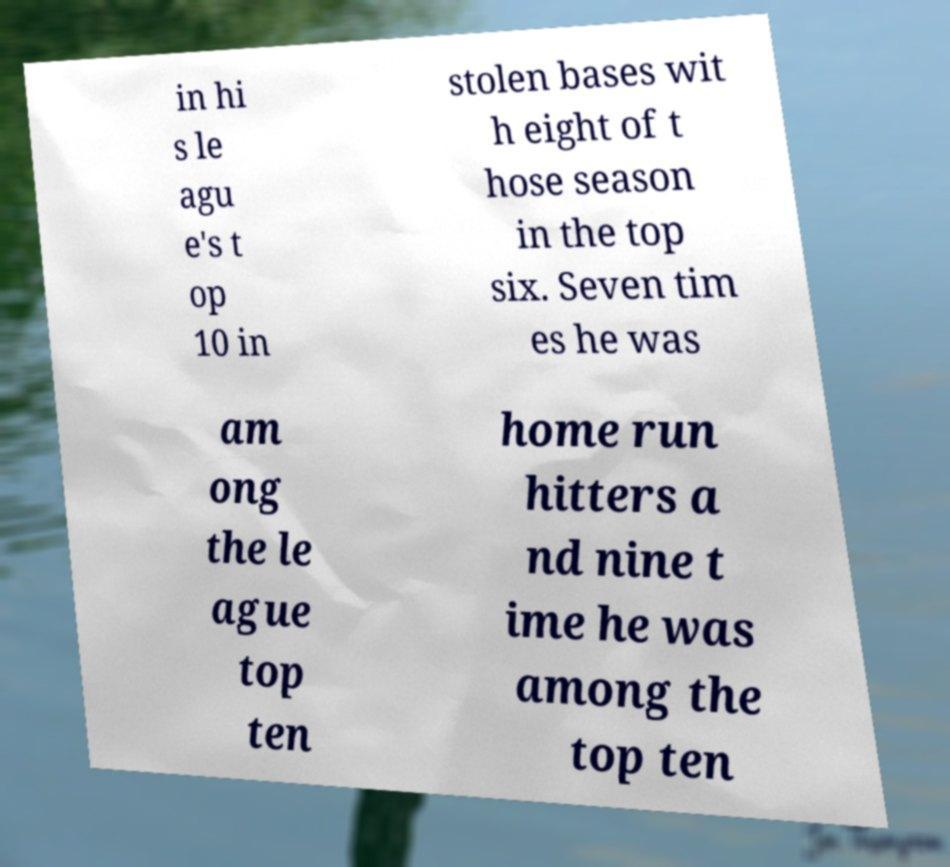Could you extract and type out the text from this image? in hi s le agu e's t op 10 in stolen bases wit h eight of t hose season in the top six. Seven tim es he was am ong the le ague top ten home run hitters a nd nine t ime he was among the top ten 